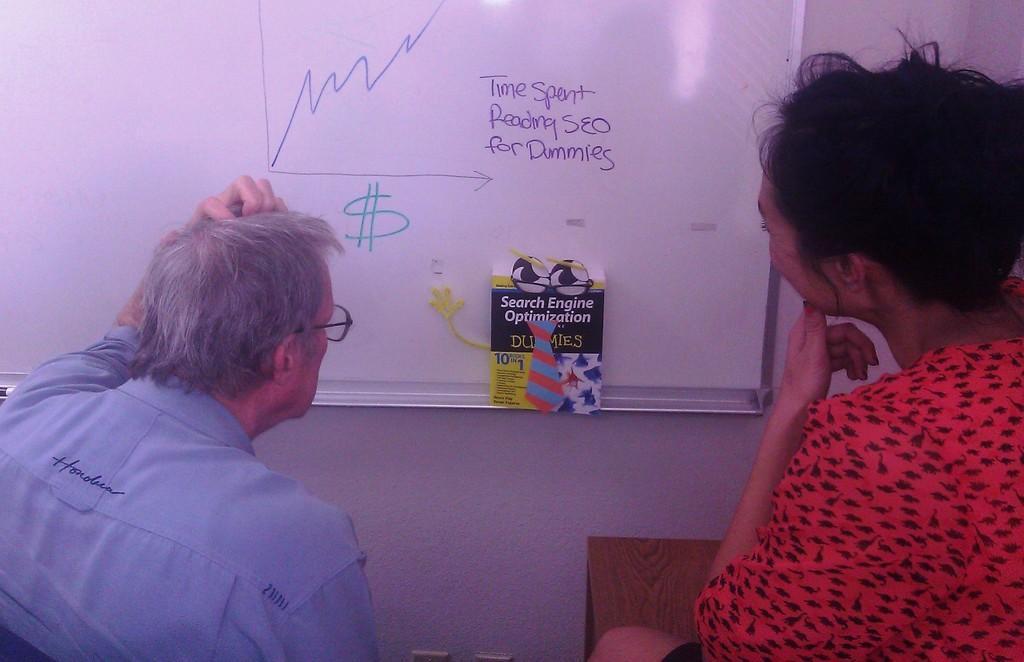In one or two sentences, can you explain what this image depicts? This image is taken indoors. On the right side of the image there is a woman. On the left side of the image there is a man. In the background there is a wall and there is a board with text on it and there is a book. 